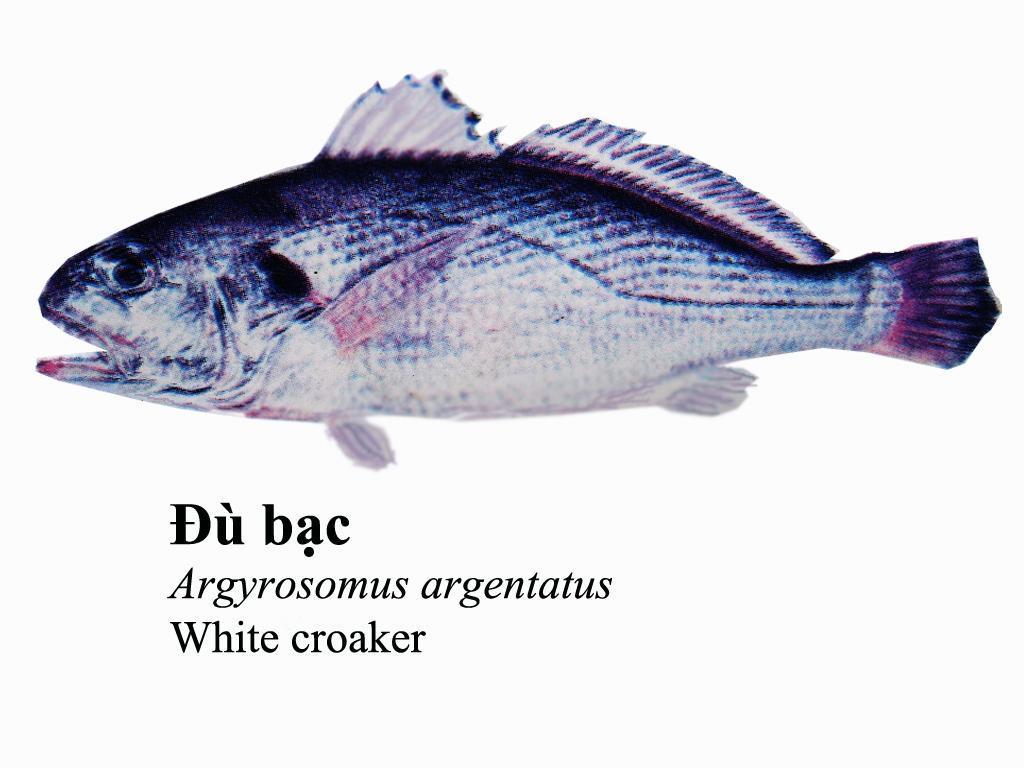In one or two sentences, can you explain what this image depicts? This image is consist of a fish and there is some text on the image. 